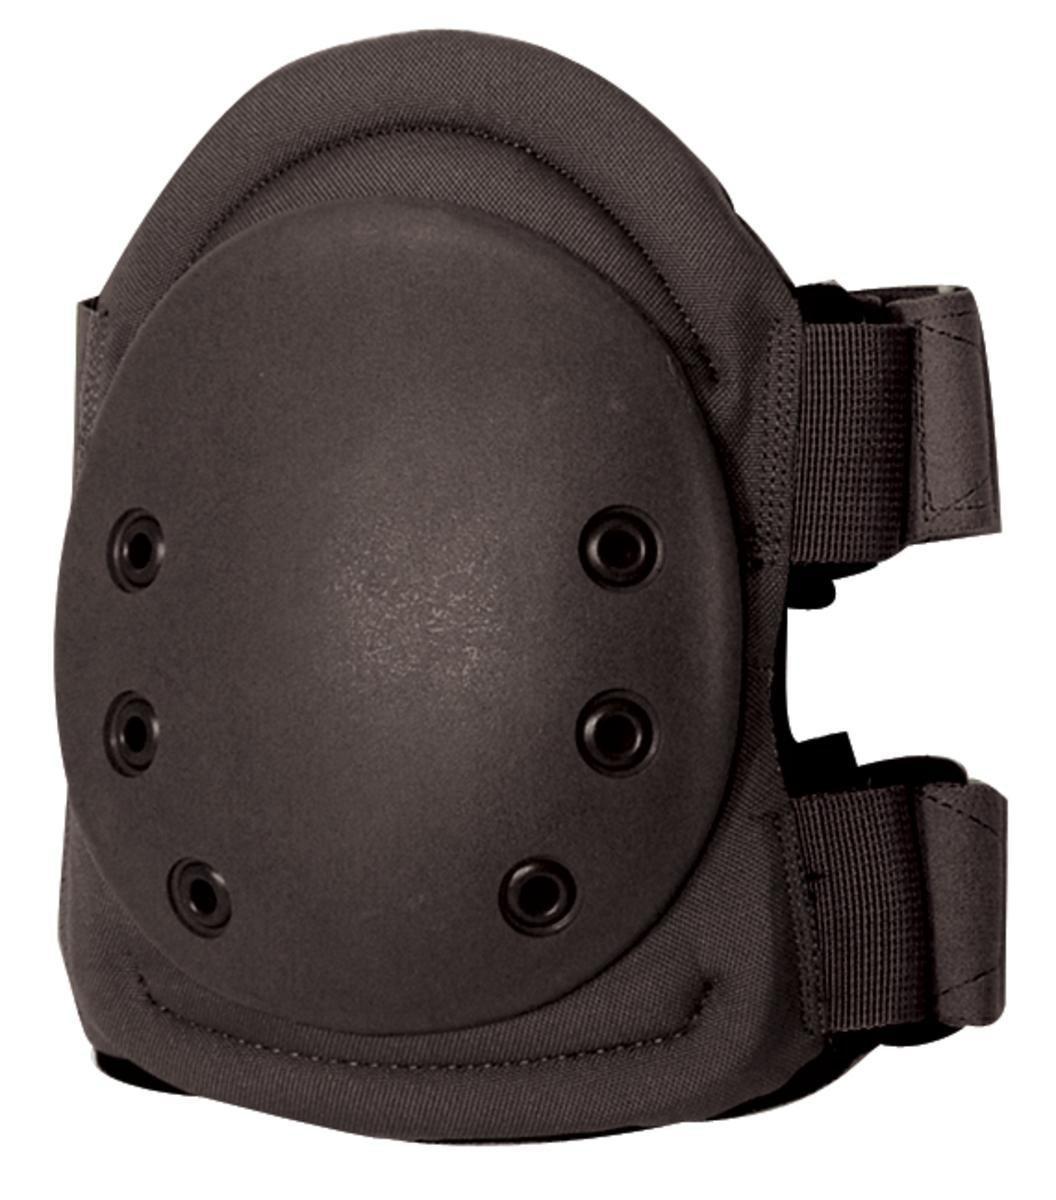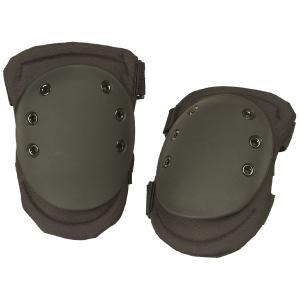The first image is the image on the left, the second image is the image on the right. Evaluate the accuracy of this statement regarding the images: "The left image contains one kneepad, while the right image contains a pair.". Is it true? Answer yes or no. Yes. The first image is the image on the left, the second image is the image on the right. Assess this claim about the two images: "There are three greyish colored pads.". Correct or not? Answer yes or no. Yes. 